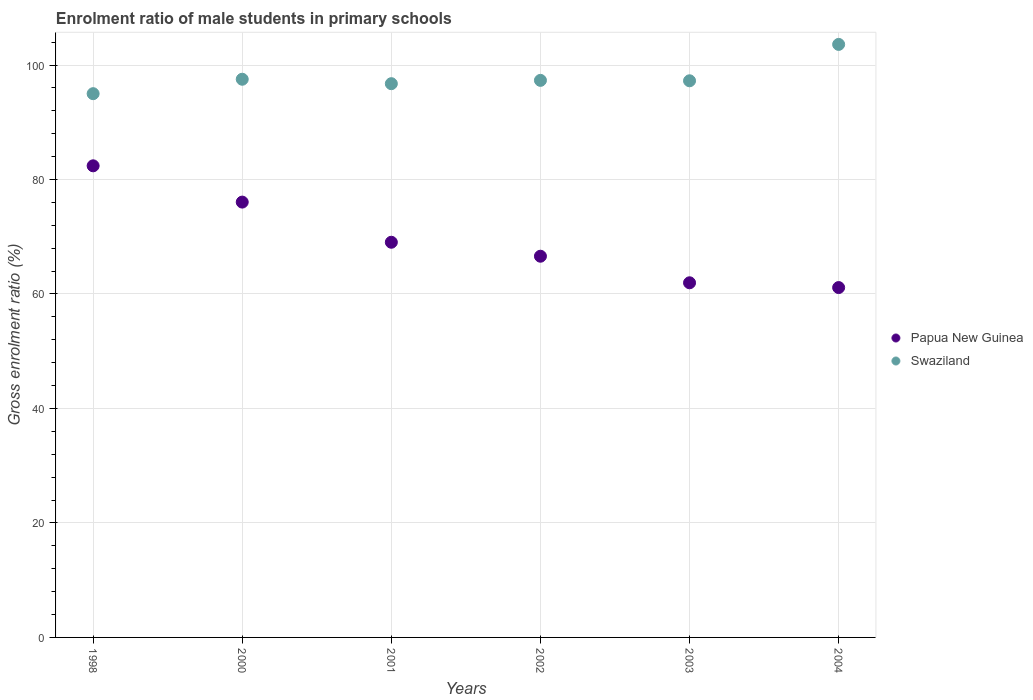Is the number of dotlines equal to the number of legend labels?
Give a very brief answer. Yes. What is the enrolment ratio of male students in primary schools in Papua New Guinea in 2002?
Make the answer very short. 66.6. Across all years, what is the maximum enrolment ratio of male students in primary schools in Papua New Guinea?
Offer a very short reply. 82.39. Across all years, what is the minimum enrolment ratio of male students in primary schools in Swaziland?
Your response must be concise. 95. What is the total enrolment ratio of male students in primary schools in Papua New Guinea in the graph?
Offer a very short reply. 417.17. What is the difference between the enrolment ratio of male students in primary schools in Papua New Guinea in 1998 and that in 2000?
Ensure brevity in your answer.  6.34. What is the difference between the enrolment ratio of male students in primary schools in Swaziland in 2004 and the enrolment ratio of male students in primary schools in Papua New Guinea in 2000?
Your response must be concise. 27.55. What is the average enrolment ratio of male students in primary schools in Swaziland per year?
Keep it short and to the point. 97.91. In the year 2002, what is the difference between the enrolment ratio of male students in primary schools in Swaziland and enrolment ratio of male students in primary schools in Papua New Guinea?
Your answer should be compact. 30.72. In how many years, is the enrolment ratio of male students in primary schools in Papua New Guinea greater than 24 %?
Provide a short and direct response. 6. What is the ratio of the enrolment ratio of male students in primary schools in Swaziland in 2000 to that in 2003?
Ensure brevity in your answer.  1. What is the difference between the highest and the second highest enrolment ratio of male students in primary schools in Papua New Guinea?
Ensure brevity in your answer.  6.34. What is the difference between the highest and the lowest enrolment ratio of male students in primary schools in Swaziland?
Provide a short and direct response. 8.61. In how many years, is the enrolment ratio of male students in primary schools in Papua New Guinea greater than the average enrolment ratio of male students in primary schools in Papua New Guinea taken over all years?
Offer a very short reply. 2. Does the enrolment ratio of male students in primary schools in Papua New Guinea monotonically increase over the years?
Offer a very short reply. No. Is the enrolment ratio of male students in primary schools in Swaziland strictly greater than the enrolment ratio of male students in primary schools in Papua New Guinea over the years?
Your answer should be compact. Yes. Are the values on the major ticks of Y-axis written in scientific E-notation?
Make the answer very short. No. Does the graph contain grids?
Give a very brief answer. Yes. How many legend labels are there?
Give a very brief answer. 2. What is the title of the graph?
Offer a very short reply. Enrolment ratio of male students in primary schools. What is the Gross enrolment ratio (%) in Papua New Guinea in 1998?
Provide a short and direct response. 82.39. What is the Gross enrolment ratio (%) of Swaziland in 1998?
Offer a terse response. 95. What is the Gross enrolment ratio (%) of Papua New Guinea in 2000?
Your response must be concise. 76.06. What is the Gross enrolment ratio (%) of Swaziland in 2000?
Keep it short and to the point. 97.52. What is the Gross enrolment ratio (%) in Papua New Guinea in 2001?
Your answer should be compact. 69.04. What is the Gross enrolment ratio (%) of Swaziland in 2001?
Provide a short and direct response. 96.74. What is the Gross enrolment ratio (%) in Papua New Guinea in 2002?
Provide a succinct answer. 66.6. What is the Gross enrolment ratio (%) of Swaziland in 2002?
Ensure brevity in your answer.  97.32. What is the Gross enrolment ratio (%) of Papua New Guinea in 2003?
Keep it short and to the point. 61.96. What is the Gross enrolment ratio (%) of Swaziland in 2003?
Offer a very short reply. 97.25. What is the Gross enrolment ratio (%) of Papua New Guinea in 2004?
Your answer should be very brief. 61.12. What is the Gross enrolment ratio (%) of Swaziland in 2004?
Make the answer very short. 103.6. Across all years, what is the maximum Gross enrolment ratio (%) of Papua New Guinea?
Ensure brevity in your answer.  82.39. Across all years, what is the maximum Gross enrolment ratio (%) in Swaziland?
Offer a terse response. 103.6. Across all years, what is the minimum Gross enrolment ratio (%) of Papua New Guinea?
Your answer should be compact. 61.12. Across all years, what is the minimum Gross enrolment ratio (%) of Swaziland?
Provide a succinct answer. 95. What is the total Gross enrolment ratio (%) in Papua New Guinea in the graph?
Make the answer very short. 417.17. What is the total Gross enrolment ratio (%) in Swaziland in the graph?
Ensure brevity in your answer.  587.44. What is the difference between the Gross enrolment ratio (%) in Papua New Guinea in 1998 and that in 2000?
Make the answer very short. 6.34. What is the difference between the Gross enrolment ratio (%) of Swaziland in 1998 and that in 2000?
Make the answer very short. -2.52. What is the difference between the Gross enrolment ratio (%) in Papua New Guinea in 1998 and that in 2001?
Your response must be concise. 13.35. What is the difference between the Gross enrolment ratio (%) of Swaziland in 1998 and that in 2001?
Offer a terse response. -1.75. What is the difference between the Gross enrolment ratio (%) in Papua New Guinea in 1998 and that in 2002?
Your answer should be compact. 15.79. What is the difference between the Gross enrolment ratio (%) of Swaziland in 1998 and that in 2002?
Offer a terse response. -2.33. What is the difference between the Gross enrolment ratio (%) of Papua New Guinea in 1998 and that in 2003?
Keep it short and to the point. 20.44. What is the difference between the Gross enrolment ratio (%) of Swaziland in 1998 and that in 2003?
Give a very brief answer. -2.25. What is the difference between the Gross enrolment ratio (%) of Papua New Guinea in 1998 and that in 2004?
Provide a short and direct response. 21.27. What is the difference between the Gross enrolment ratio (%) of Swaziland in 1998 and that in 2004?
Ensure brevity in your answer.  -8.61. What is the difference between the Gross enrolment ratio (%) in Papua New Guinea in 2000 and that in 2001?
Provide a succinct answer. 7.02. What is the difference between the Gross enrolment ratio (%) in Swaziland in 2000 and that in 2001?
Make the answer very short. 0.78. What is the difference between the Gross enrolment ratio (%) in Papua New Guinea in 2000 and that in 2002?
Give a very brief answer. 9.46. What is the difference between the Gross enrolment ratio (%) in Swaziland in 2000 and that in 2002?
Your answer should be compact. 0.2. What is the difference between the Gross enrolment ratio (%) of Papua New Guinea in 2000 and that in 2003?
Provide a succinct answer. 14.1. What is the difference between the Gross enrolment ratio (%) in Swaziland in 2000 and that in 2003?
Your response must be concise. 0.27. What is the difference between the Gross enrolment ratio (%) of Papua New Guinea in 2000 and that in 2004?
Make the answer very short. 14.93. What is the difference between the Gross enrolment ratio (%) of Swaziland in 2000 and that in 2004?
Provide a short and direct response. -6.09. What is the difference between the Gross enrolment ratio (%) of Papua New Guinea in 2001 and that in 2002?
Your answer should be very brief. 2.44. What is the difference between the Gross enrolment ratio (%) of Swaziland in 2001 and that in 2002?
Your answer should be very brief. -0.58. What is the difference between the Gross enrolment ratio (%) of Papua New Guinea in 2001 and that in 2003?
Offer a terse response. 7.08. What is the difference between the Gross enrolment ratio (%) in Swaziland in 2001 and that in 2003?
Offer a very short reply. -0.51. What is the difference between the Gross enrolment ratio (%) in Papua New Guinea in 2001 and that in 2004?
Give a very brief answer. 7.92. What is the difference between the Gross enrolment ratio (%) in Swaziland in 2001 and that in 2004?
Provide a succinct answer. -6.86. What is the difference between the Gross enrolment ratio (%) in Papua New Guinea in 2002 and that in 2003?
Give a very brief answer. 4.64. What is the difference between the Gross enrolment ratio (%) in Swaziland in 2002 and that in 2003?
Ensure brevity in your answer.  0.07. What is the difference between the Gross enrolment ratio (%) of Papua New Guinea in 2002 and that in 2004?
Make the answer very short. 5.48. What is the difference between the Gross enrolment ratio (%) in Swaziland in 2002 and that in 2004?
Your answer should be compact. -6.28. What is the difference between the Gross enrolment ratio (%) of Papua New Guinea in 2003 and that in 2004?
Your answer should be very brief. 0.83. What is the difference between the Gross enrolment ratio (%) of Swaziland in 2003 and that in 2004?
Offer a terse response. -6.36. What is the difference between the Gross enrolment ratio (%) in Papua New Guinea in 1998 and the Gross enrolment ratio (%) in Swaziland in 2000?
Offer a very short reply. -15.13. What is the difference between the Gross enrolment ratio (%) in Papua New Guinea in 1998 and the Gross enrolment ratio (%) in Swaziland in 2001?
Give a very brief answer. -14.35. What is the difference between the Gross enrolment ratio (%) in Papua New Guinea in 1998 and the Gross enrolment ratio (%) in Swaziland in 2002?
Provide a succinct answer. -14.93. What is the difference between the Gross enrolment ratio (%) of Papua New Guinea in 1998 and the Gross enrolment ratio (%) of Swaziland in 2003?
Your answer should be compact. -14.86. What is the difference between the Gross enrolment ratio (%) in Papua New Guinea in 1998 and the Gross enrolment ratio (%) in Swaziland in 2004?
Offer a terse response. -21.21. What is the difference between the Gross enrolment ratio (%) in Papua New Guinea in 2000 and the Gross enrolment ratio (%) in Swaziland in 2001?
Your answer should be very brief. -20.69. What is the difference between the Gross enrolment ratio (%) in Papua New Guinea in 2000 and the Gross enrolment ratio (%) in Swaziland in 2002?
Your answer should be very brief. -21.27. What is the difference between the Gross enrolment ratio (%) of Papua New Guinea in 2000 and the Gross enrolment ratio (%) of Swaziland in 2003?
Make the answer very short. -21.19. What is the difference between the Gross enrolment ratio (%) of Papua New Guinea in 2000 and the Gross enrolment ratio (%) of Swaziland in 2004?
Your response must be concise. -27.55. What is the difference between the Gross enrolment ratio (%) of Papua New Guinea in 2001 and the Gross enrolment ratio (%) of Swaziland in 2002?
Offer a very short reply. -28.28. What is the difference between the Gross enrolment ratio (%) in Papua New Guinea in 2001 and the Gross enrolment ratio (%) in Swaziland in 2003?
Give a very brief answer. -28.21. What is the difference between the Gross enrolment ratio (%) in Papua New Guinea in 2001 and the Gross enrolment ratio (%) in Swaziland in 2004?
Ensure brevity in your answer.  -34.56. What is the difference between the Gross enrolment ratio (%) of Papua New Guinea in 2002 and the Gross enrolment ratio (%) of Swaziland in 2003?
Ensure brevity in your answer.  -30.65. What is the difference between the Gross enrolment ratio (%) in Papua New Guinea in 2002 and the Gross enrolment ratio (%) in Swaziland in 2004?
Keep it short and to the point. -37.01. What is the difference between the Gross enrolment ratio (%) of Papua New Guinea in 2003 and the Gross enrolment ratio (%) of Swaziland in 2004?
Your answer should be compact. -41.65. What is the average Gross enrolment ratio (%) of Papua New Guinea per year?
Your response must be concise. 69.53. What is the average Gross enrolment ratio (%) of Swaziland per year?
Give a very brief answer. 97.91. In the year 1998, what is the difference between the Gross enrolment ratio (%) of Papua New Guinea and Gross enrolment ratio (%) of Swaziland?
Your response must be concise. -12.6. In the year 2000, what is the difference between the Gross enrolment ratio (%) in Papua New Guinea and Gross enrolment ratio (%) in Swaziland?
Offer a very short reply. -21.46. In the year 2001, what is the difference between the Gross enrolment ratio (%) in Papua New Guinea and Gross enrolment ratio (%) in Swaziland?
Ensure brevity in your answer.  -27.7. In the year 2002, what is the difference between the Gross enrolment ratio (%) of Papua New Guinea and Gross enrolment ratio (%) of Swaziland?
Provide a short and direct response. -30.72. In the year 2003, what is the difference between the Gross enrolment ratio (%) in Papua New Guinea and Gross enrolment ratio (%) in Swaziland?
Your response must be concise. -35.29. In the year 2004, what is the difference between the Gross enrolment ratio (%) in Papua New Guinea and Gross enrolment ratio (%) in Swaziland?
Offer a very short reply. -42.48. What is the ratio of the Gross enrolment ratio (%) in Papua New Guinea in 1998 to that in 2000?
Your answer should be compact. 1.08. What is the ratio of the Gross enrolment ratio (%) of Swaziland in 1998 to that in 2000?
Your answer should be compact. 0.97. What is the ratio of the Gross enrolment ratio (%) in Papua New Guinea in 1998 to that in 2001?
Make the answer very short. 1.19. What is the ratio of the Gross enrolment ratio (%) in Swaziland in 1998 to that in 2001?
Keep it short and to the point. 0.98. What is the ratio of the Gross enrolment ratio (%) in Papua New Guinea in 1998 to that in 2002?
Your answer should be compact. 1.24. What is the ratio of the Gross enrolment ratio (%) of Swaziland in 1998 to that in 2002?
Make the answer very short. 0.98. What is the ratio of the Gross enrolment ratio (%) of Papua New Guinea in 1998 to that in 2003?
Provide a succinct answer. 1.33. What is the ratio of the Gross enrolment ratio (%) of Swaziland in 1998 to that in 2003?
Offer a terse response. 0.98. What is the ratio of the Gross enrolment ratio (%) in Papua New Guinea in 1998 to that in 2004?
Give a very brief answer. 1.35. What is the ratio of the Gross enrolment ratio (%) of Swaziland in 1998 to that in 2004?
Give a very brief answer. 0.92. What is the ratio of the Gross enrolment ratio (%) of Papua New Guinea in 2000 to that in 2001?
Your answer should be compact. 1.1. What is the ratio of the Gross enrolment ratio (%) of Papua New Guinea in 2000 to that in 2002?
Provide a short and direct response. 1.14. What is the ratio of the Gross enrolment ratio (%) of Swaziland in 2000 to that in 2002?
Offer a terse response. 1. What is the ratio of the Gross enrolment ratio (%) of Papua New Guinea in 2000 to that in 2003?
Your answer should be compact. 1.23. What is the ratio of the Gross enrolment ratio (%) in Swaziland in 2000 to that in 2003?
Make the answer very short. 1. What is the ratio of the Gross enrolment ratio (%) in Papua New Guinea in 2000 to that in 2004?
Keep it short and to the point. 1.24. What is the ratio of the Gross enrolment ratio (%) in Swaziland in 2000 to that in 2004?
Make the answer very short. 0.94. What is the ratio of the Gross enrolment ratio (%) of Papua New Guinea in 2001 to that in 2002?
Make the answer very short. 1.04. What is the ratio of the Gross enrolment ratio (%) of Swaziland in 2001 to that in 2002?
Your answer should be compact. 0.99. What is the ratio of the Gross enrolment ratio (%) in Papua New Guinea in 2001 to that in 2003?
Keep it short and to the point. 1.11. What is the ratio of the Gross enrolment ratio (%) of Papua New Guinea in 2001 to that in 2004?
Ensure brevity in your answer.  1.13. What is the ratio of the Gross enrolment ratio (%) in Swaziland in 2001 to that in 2004?
Your answer should be compact. 0.93. What is the ratio of the Gross enrolment ratio (%) of Papua New Guinea in 2002 to that in 2003?
Offer a terse response. 1.07. What is the ratio of the Gross enrolment ratio (%) of Swaziland in 2002 to that in 2003?
Offer a terse response. 1. What is the ratio of the Gross enrolment ratio (%) in Papua New Guinea in 2002 to that in 2004?
Keep it short and to the point. 1.09. What is the ratio of the Gross enrolment ratio (%) of Swaziland in 2002 to that in 2004?
Keep it short and to the point. 0.94. What is the ratio of the Gross enrolment ratio (%) of Papua New Guinea in 2003 to that in 2004?
Provide a succinct answer. 1.01. What is the ratio of the Gross enrolment ratio (%) of Swaziland in 2003 to that in 2004?
Your answer should be compact. 0.94. What is the difference between the highest and the second highest Gross enrolment ratio (%) in Papua New Guinea?
Offer a very short reply. 6.34. What is the difference between the highest and the second highest Gross enrolment ratio (%) in Swaziland?
Provide a short and direct response. 6.09. What is the difference between the highest and the lowest Gross enrolment ratio (%) of Papua New Guinea?
Your response must be concise. 21.27. What is the difference between the highest and the lowest Gross enrolment ratio (%) in Swaziland?
Offer a terse response. 8.61. 